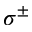<formula> <loc_0><loc_0><loc_500><loc_500>\sigma ^ { \pm }</formula> 